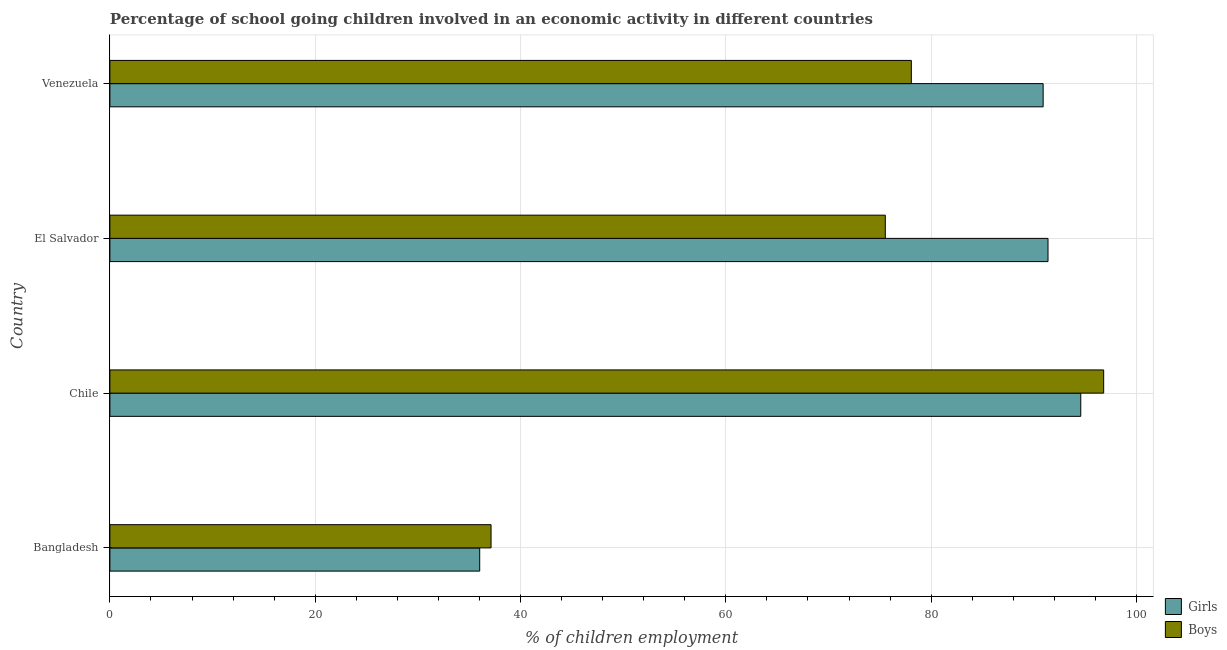How many different coloured bars are there?
Keep it short and to the point. 2. How many bars are there on the 2nd tick from the top?
Ensure brevity in your answer.  2. What is the label of the 3rd group of bars from the top?
Your answer should be compact. Chile. What is the percentage of school going girls in Venezuela?
Your response must be concise. 90.91. Across all countries, what is the maximum percentage of school going girls?
Offer a terse response. 94.57. Across all countries, what is the minimum percentage of school going boys?
Offer a terse response. 37.13. In which country was the percentage of school going boys minimum?
Provide a succinct answer. Bangladesh. What is the total percentage of school going girls in the graph?
Your answer should be compact. 312.89. What is the difference between the percentage of school going girls in Chile and that in Venezuela?
Offer a very short reply. 3.67. What is the difference between the percentage of school going girls in Bangladesh and the percentage of school going boys in Venezuela?
Your answer should be compact. -42.05. What is the average percentage of school going girls per country?
Give a very brief answer. 78.22. What is the difference between the percentage of school going boys and percentage of school going girls in Bangladesh?
Provide a succinct answer. 1.1. What is the ratio of the percentage of school going boys in Bangladesh to that in Chile?
Ensure brevity in your answer.  0.38. Is the difference between the percentage of school going girls in Chile and El Salvador greater than the difference between the percentage of school going boys in Chile and El Salvador?
Ensure brevity in your answer.  No. What is the difference between the highest and the second highest percentage of school going girls?
Your answer should be compact. 3.19. What is the difference between the highest and the lowest percentage of school going boys?
Make the answer very short. 59.68. Is the sum of the percentage of school going boys in Chile and Venezuela greater than the maximum percentage of school going girls across all countries?
Your answer should be compact. Yes. What does the 2nd bar from the top in Venezuela represents?
Your response must be concise. Girls. What does the 1st bar from the bottom in Venezuela represents?
Keep it short and to the point. Girls. How many bars are there?
Make the answer very short. 8. Are all the bars in the graph horizontal?
Keep it short and to the point. Yes. What is the difference between two consecutive major ticks on the X-axis?
Offer a terse response. 20. Where does the legend appear in the graph?
Provide a succinct answer. Bottom right. What is the title of the graph?
Your response must be concise. Percentage of school going children involved in an economic activity in different countries. Does "Secondary Education" appear as one of the legend labels in the graph?
Your answer should be very brief. No. What is the label or title of the X-axis?
Offer a terse response. % of children employment. What is the label or title of the Y-axis?
Your response must be concise. Country. What is the % of children employment in Girls in Bangladesh?
Your answer should be compact. 36.02. What is the % of children employment in Boys in Bangladesh?
Offer a terse response. 37.13. What is the % of children employment in Girls in Chile?
Make the answer very short. 94.57. What is the % of children employment in Boys in Chile?
Offer a very short reply. 96.81. What is the % of children employment in Girls in El Salvador?
Offer a terse response. 91.38. What is the % of children employment in Boys in El Salvador?
Give a very brief answer. 75.53. What is the % of children employment in Girls in Venezuela?
Make the answer very short. 90.91. What is the % of children employment in Boys in Venezuela?
Offer a very short reply. 78.07. Across all countries, what is the maximum % of children employment of Girls?
Keep it short and to the point. 94.57. Across all countries, what is the maximum % of children employment of Boys?
Your response must be concise. 96.81. Across all countries, what is the minimum % of children employment in Girls?
Ensure brevity in your answer.  36.02. Across all countries, what is the minimum % of children employment in Boys?
Your response must be concise. 37.13. What is the total % of children employment in Girls in the graph?
Ensure brevity in your answer.  312.89. What is the total % of children employment in Boys in the graph?
Your response must be concise. 287.54. What is the difference between the % of children employment in Girls in Bangladesh and that in Chile?
Ensure brevity in your answer.  -58.55. What is the difference between the % of children employment in Boys in Bangladesh and that in Chile?
Your response must be concise. -59.68. What is the difference between the % of children employment in Girls in Bangladesh and that in El Salvador?
Ensure brevity in your answer.  -55.36. What is the difference between the % of children employment of Boys in Bangladesh and that in El Salvador?
Your answer should be very brief. -38.4. What is the difference between the % of children employment of Girls in Bangladesh and that in Venezuela?
Your answer should be compact. -54.88. What is the difference between the % of children employment in Boys in Bangladesh and that in Venezuela?
Ensure brevity in your answer.  -40.94. What is the difference between the % of children employment of Girls in Chile and that in El Salvador?
Keep it short and to the point. 3.19. What is the difference between the % of children employment in Boys in Chile and that in El Salvador?
Provide a succinct answer. 21.27. What is the difference between the % of children employment of Girls in Chile and that in Venezuela?
Keep it short and to the point. 3.67. What is the difference between the % of children employment in Boys in Chile and that in Venezuela?
Keep it short and to the point. 18.74. What is the difference between the % of children employment in Girls in El Salvador and that in Venezuela?
Your answer should be compact. 0.47. What is the difference between the % of children employment of Boys in El Salvador and that in Venezuela?
Your answer should be very brief. -2.54. What is the difference between the % of children employment in Girls in Bangladesh and the % of children employment in Boys in Chile?
Make the answer very short. -60.78. What is the difference between the % of children employment of Girls in Bangladesh and the % of children employment of Boys in El Salvador?
Ensure brevity in your answer.  -39.51. What is the difference between the % of children employment of Girls in Bangladesh and the % of children employment of Boys in Venezuela?
Keep it short and to the point. -42.05. What is the difference between the % of children employment of Girls in Chile and the % of children employment of Boys in El Salvador?
Make the answer very short. 19.04. What is the difference between the % of children employment of Girls in Chile and the % of children employment of Boys in Venezuela?
Give a very brief answer. 16.5. What is the difference between the % of children employment of Girls in El Salvador and the % of children employment of Boys in Venezuela?
Keep it short and to the point. 13.31. What is the average % of children employment of Girls per country?
Your answer should be compact. 78.22. What is the average % of children employment in Boys per country?
Offer a terse response. 71.88. What is the difference between the % of children employment in Girls and % of children employment in Boys in Bangladesh?
Your answer should be compact. -1.11. What is the difference between the % of children employment of Girls and % of children employment of Boys in Chile?
Give a very brief answer. -2.23. What is the difference between the % of children employment in Girls and % of children employment in Boys in El Salvador?
Your answer should be very brief. 15.85. What is the difference between the % of children employment in Girls and % of children employment in Boys in Venezuela?
Your response must be concise. 12.84. What is the ratio of the % of children employment in Girls in Bangladesh to that in Chile?
Provide a short and direct response. 0.38. What is the ratio of the % of children employment in Boys in Bangladesh to that in Chile?
Ensure brevity in your answer.  0.38. What is the ratio of the % of children employment of Girls in Bangladesh to that in El Salvador?
Ensure brevity in your answer.  0.39. What is the ratio of the % of children employment of Boys in Bangladesh to that in El Salvador?
Your answer should be very brief. 0.49. What is the ratio of the % of children employment in Girls in Bangladesh to that in Venezuela?
Your answer should be compact. 0.4. What is the ratio of the % of children employment of Boys in Bangladesh to that in Venezuela?
Your answer should be compact. 0.48. What is the ratio of the % of children employment of Girls in Chile to that in El Salvador?
Keep it short and to the point. 1.03. What is the ratio of the % of children employment of Boys in Chile to that in El Salvador?
Provide a short and direct response. 1.28. What is the ratio of the % of children employment of Girls in Chile to that in Venezuela?
Keep it short and to the point. 1.04. What is the ratio of the % of children employment in Boys in Chile to that in Venezuela?
Your answer should be compact. 1.24. What is the ratio of the % of children employment of Girls in El Salvador to that in Venezuela?
Keep it short and to the point. 1.01. What is the ratio of the % of children employment of Boys in El Salvador to that in Venezuela?
Provide a succinct answer. 0.97. What is the difference between the highest and the second highest % of children employment of Girls?
Provide a succinct answer. 3.19. What is the difference between the highest and the second highest % of children employment in Boys?
Make the answer very short. 18.74. What is the difference between the highest and the lowest % of children employment of Girls?
Your response must be concise. 58.55. What is the difference between the highest and the lowest % of children employment of Boys?
Your response must be concise. 59.68. 